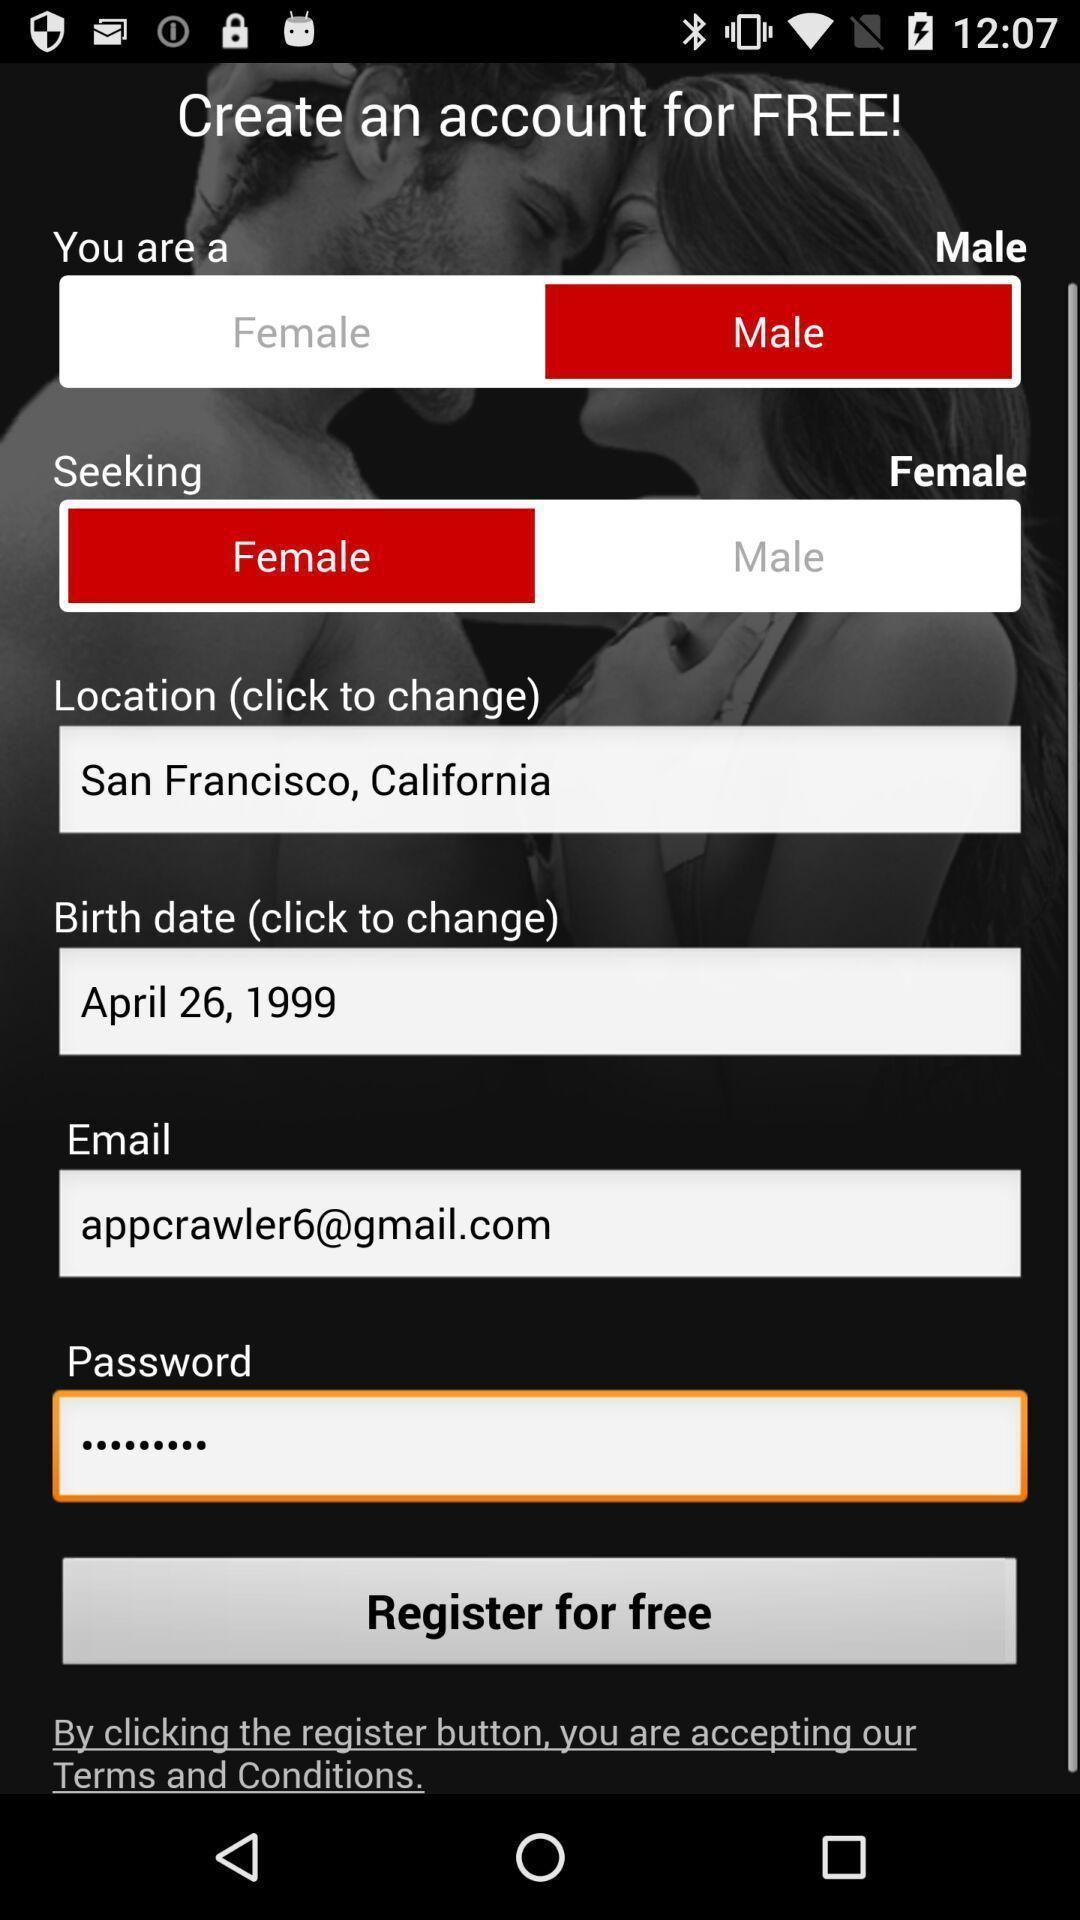Describe this image in words. Sign up page for creating account on social app. 